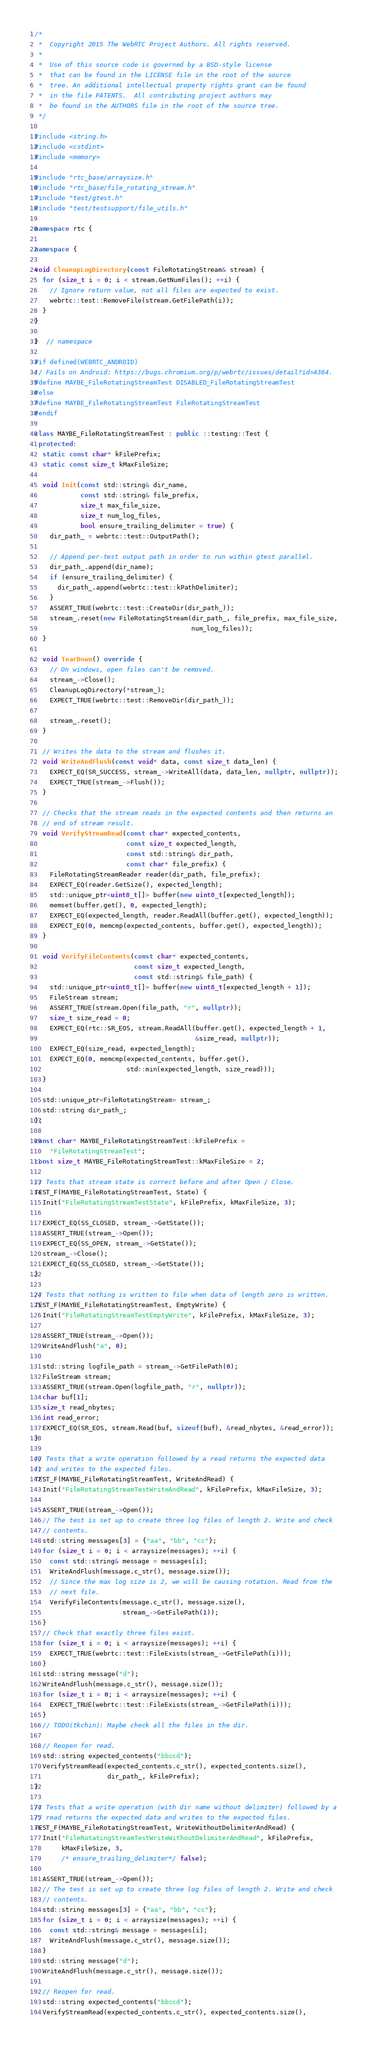Convert code to text. <code><loc_0><loc_0><loc_500><loc_500><_C++_>/*
 *  Copyright 2015 The WebRTC Project Authors. All rights reserved.
 *
 *  Use of this source code is governed by a BSD-style license
 *  that can be found in the LICENSE file in the root of the source
 *  tree. An additional intellectual property rights grant can be found
 *  in the file PATENTS.  All contributing project authors may
 *  be found in the AUTHORS file in the root of the source tree.
 */

#include <string.h>
#include <cstdint>
#include <memory>

#include "rtc_base/arraysize.h"
#include "rtc_base/file_rotating_stream.h"
#include "test/gtest.h"
#include "test/testsupport/file_utils.h"

namespace rtc {

namespace {

void CleanupLogDirectory(const FileRotatingStream& stream) {
  for (size_t i = 0; i < stream.GetNumFiles(); ++i) {
    // Ignore return value, not all files are expected to exist.
    webrtc::test::RemoveFile(stream.GetFilePath(i));
  }
}

}  // namespace

#if defined(WEBRTC_ANDROID)
// Fails on Android: https://bugs.chromium.org/p/webrtc/issues/detail?id=4364.
#define MAYBE_FileRotatingStreamTest DISABLED_FileRotatingStreamTest
#else
#define MAYBE_FileRotatingStreamTest FileRotatingStreamTest
#endif

class MAYBE_FileRotatingStreamTest : public ::testing::Test {
 protected:
  static const char* kFilePrefix;
  static const size_t kMaxFileSize;

  void Init(const std::string& dir_name,
            const std::string& file_prefix,
            size_t max_file_size,
            size_t num_log_files,
            bool ensure_trailing_delimiter = true) {
    dir_path_ = webrtc::test::OutputPath();

    // Append per-test output path in order to run within gtest parallel.
    dir_path_.append(dir_name);
    if (ensure_trailing_delimiter) {
      dir_path_.append(webrtc::test::kPathDelimiter);
    }
    ASSERT_TRUE(webrtc::test::CreateDir(dir_path_));
    stream_.reset(new FileRotatingStream(dir_path_, file_prefix, max_file_size,
                                         num_log_files));
  }

  void TearDown() override {
    // On windows, open files can't be removed.
    stream_->Close();
    CleanupLogDirectory(*stream_);
    EXPECT_TRUE(webrtc::test::RemoveDir(dir_path_));

    stream_.reset();
  }

  // Writes the data to the stream and flushes it.
  void WriteAndFlush(const void* data, const size_t data_len) {
    EXPECT_EQ(SR_SUCCESS, stream_->WriteAll(data, data_len, nullptr, nullptr));
    EXPECT_TRUE(stream_->Flush());
  }

  // Checks that the stream reads in the expected contents and then returns an
  // end of stream result.
  void VerifyStreamRead(const char* expected_contents,
                        const size_t expected_length,
                        const std::string& dir_path,
                        const char* file_prefix) {
    FileRotatingStreamReader reader(dir_path, file_prefix);
    EXPECT_EQ(reader.GetSize(), expected_length);
    std::unique_ptr<uint8_t[]> buffer(new uint8_t[expected_length]);
    memset(buffer.get(), 0, expected_length);
    EXPECT_EQ(expected_length, reader.ReadAll(buffer.get(), expected_length));
    EXPECT_EQ(0, memcmp(expected_contents, buffer.get(), expected_length));
  }

  void VerifyFileContents(const char* expected_contents,
                          const size_t expected_length,
                          const std::string& file_path) {
    std::unique_ptr<uint8_t[]> buffer(new uint8_t[expected_length + 1]);
    FileStream stream;
    ASSERT_TRUE(stream.Open(file_path, "r", nullptr));
    size_t size_read = 0;
    EXPECT_EQ(rtc::SR_EOS, stream.ReadAll(buffer.get(), expected_length + 1,
                                          &size_read, nullptr));
    EXPECT_EQ(size_read, expected_length);
    EXPECT_EQ(0, memcmp(expected_contents, buffer.get(),
                        std::min(expected_length, size_read)));
  }

  std::unique_ptr<FileRotatingStream> stream_;
  std::string dir_path_;
};

const char* MAYBE_FileRotatingStreamTest::kFilePrefix =
    "FileRotatingStreamTest";
const size_t MAYBE_FileRotatingStreamTest::kMaxFileSize = 2;

// Tests that stream state is correct before and after Open / Close.
TEST_F(MAYBE_FileRotatingStreamTest, State) {
  Init("FileRotatingStreamTestState", kFilePrefix, kMaxFileSize, 3);

  EXPECT_EQ(SS_CLOSED, stream_->GetState());
  ASSERT_TRUE(stream_->Open());
  EXPECT_EQ(SS_OPEN, stream_->GetState());
  stream_->Close();
  EXPECT_EQ(SS_CLOSED, stream_->GetState());
}

// Tests that nothing is written to file when data of length zero is written.
TEST_F(MAYBE_FileRotatingStreamTest, EmptyWrite) {
  Init("FileRotatingStreamTestEmptyWrite", kFilePrefix, kMaxFileSize, 3);

  ASSERT_TRUE(stream_->Open());
  WriteAndFlush("a", 0);

  std::string logfile_path = stream_->GetFilePath(0);
  FileStream stream;
  ASSERT_TRUE(stream.Open(logfile_path, "r", nullptr));
  char buf[1];
  size_t read_nbytes;
  int read_error;
  EXPECT_EQ(SR_EOS, stream.Read(buf, sizeof(buf), &read_nbytes, &read_error));
}

// Tests that a write operation followed by a read returns the expected data
// and writes to the expected files.
TEST_F(MAYBE_FileRotatingStreamTest, WriteAndRead) {
  Init("FileRotatingStreamTestWriteAndRead", kFilePrefix, kMaxFileSize, 3);

  ASSERT_TRUE(stream_->Open());
  // The test is set up to create three log files of length 2. Write and check
  // contents.
  std::string messages[3] = {"aa", "bb", "cc"};
  for (size_t i = 0; i < arraysize(messages); ++i) {
    const std::string& message = messages[i];
    WriteAndFlush(message.c_str(), message.size());
    // Since the max log size is 2, we will be causing rotation. Read from the
    // next file.
    VerifyFileContents(message.c_str(), message.size(),
                       stream_->GetFilePath(1));
  }
  // Check that exactly three files exist.
  for (size_t i = 0; i < arraysize(messages); ++i) {
    EXPECT_TRUE(webrtc::test::FileExists(stream_->GetFilePath(i)));
  }
  std::string message("d");
  WriteAndFlush(message.c_str(), message.size());
  for (size_t i = 0; i < arraysize(messages); ++i) {
    EXPECT_TRUE(webrtc::test::FileExists(stream_->GetFilePath(i)));
  }
  // TODO(tkchin): Maybe check all the files in the dir.

  // Reopen for read.
  std::string expected_contents("bbccd");
  VerifyStreamRead(expected_contents.c_str(), expected_contents.size(),
                   dir_path_, kFilePrefix);
}

// Tests that a write operation (with dir name without delimiter) followed by a
// read returns the expected data and writes to the expected files.
TEST_F(MAYBE_FileRotatingStreamTest, WriteWithoutDelimiterAndRead) {
  Init("FileRotatingStreamTestWriteWithoutDelimiterAndRead", kFilePrefix,
       kMaxFileSize, 3,
       /* ensure_trailing_delimiter*/ false);

  ASSERT_TRUE(stream_->Open());
  // The test is set up to create three log files of length 2. Write and check
  // contents.
  std::string messages[3] = {"aa", "bb", "cc"};
  for (size_t i = 0; i < arraysize(messages); ++i) {
    const std::string& message = messages[i];
    WriteAndFlush(message.c_str(), message.size());
  }
  std::string message("d");
  WriteAndFlush(message.c_str(), message.size());

  // Reopen for read.
  std::string expected_contents("bbccd");
  VerifyStreamRead(expected_contents.c_str(), expected_contents.size(),</code> 